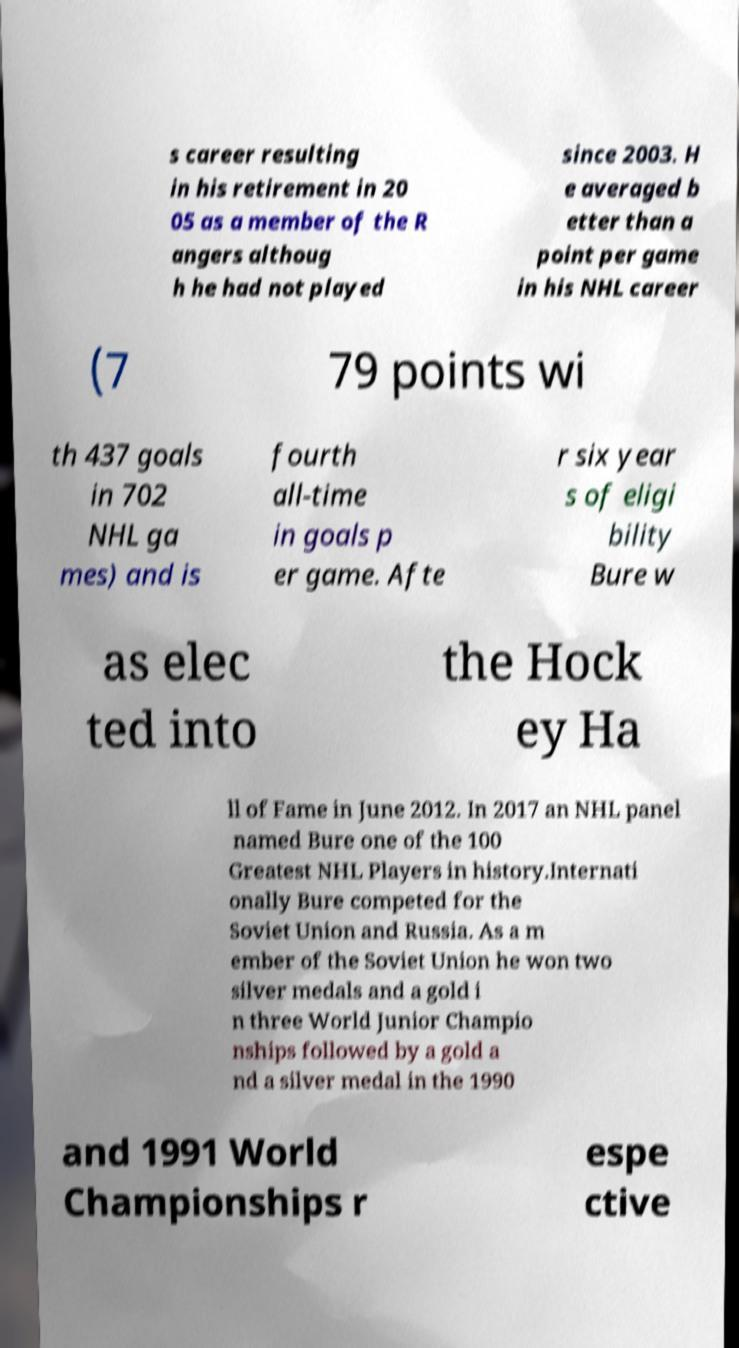Can you read and provide the text displayed in the image?This photo seems to have some interesting text. Can you extract and type it out for me? s career resulting in his retirement in 20 05 as a member of the R angers althoug h he had not played since 2003. H e averaged b etter than a point per game in his NHL career (7 79 points wi th 437 goals in 702 NHL ga mes) and is fourth all-time in goals p er game. Afte r six year s of eligi bility Bure w as elec ted into the Hock ey Ha ll of Fame in June 2012. In 2017 an NHL panel named Bure one of the 100 Greatest NHL Players in history.Internati onally Bure competed for the Soviet Union and Russia. As a m ember of the Soviet Union he won two silver medals and a gold i n three World Junior Champio nships followed by a gold a nd a silver medal in the 1990 and 1991 World Championships r espe ctive 